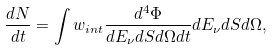Convert formula to latex. <formula><loc_0><loc_0><loc_500><loc_500>\frac { d N } { d t } = \int w _ { i n t } \frac { d ^ { 4 } \Phi } { d E _ { \nu } d S d \Omega d t } d E _ { \nu } d S d \Omega ,</formula> 